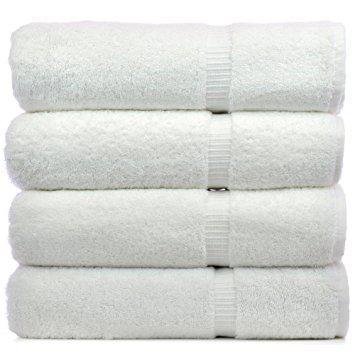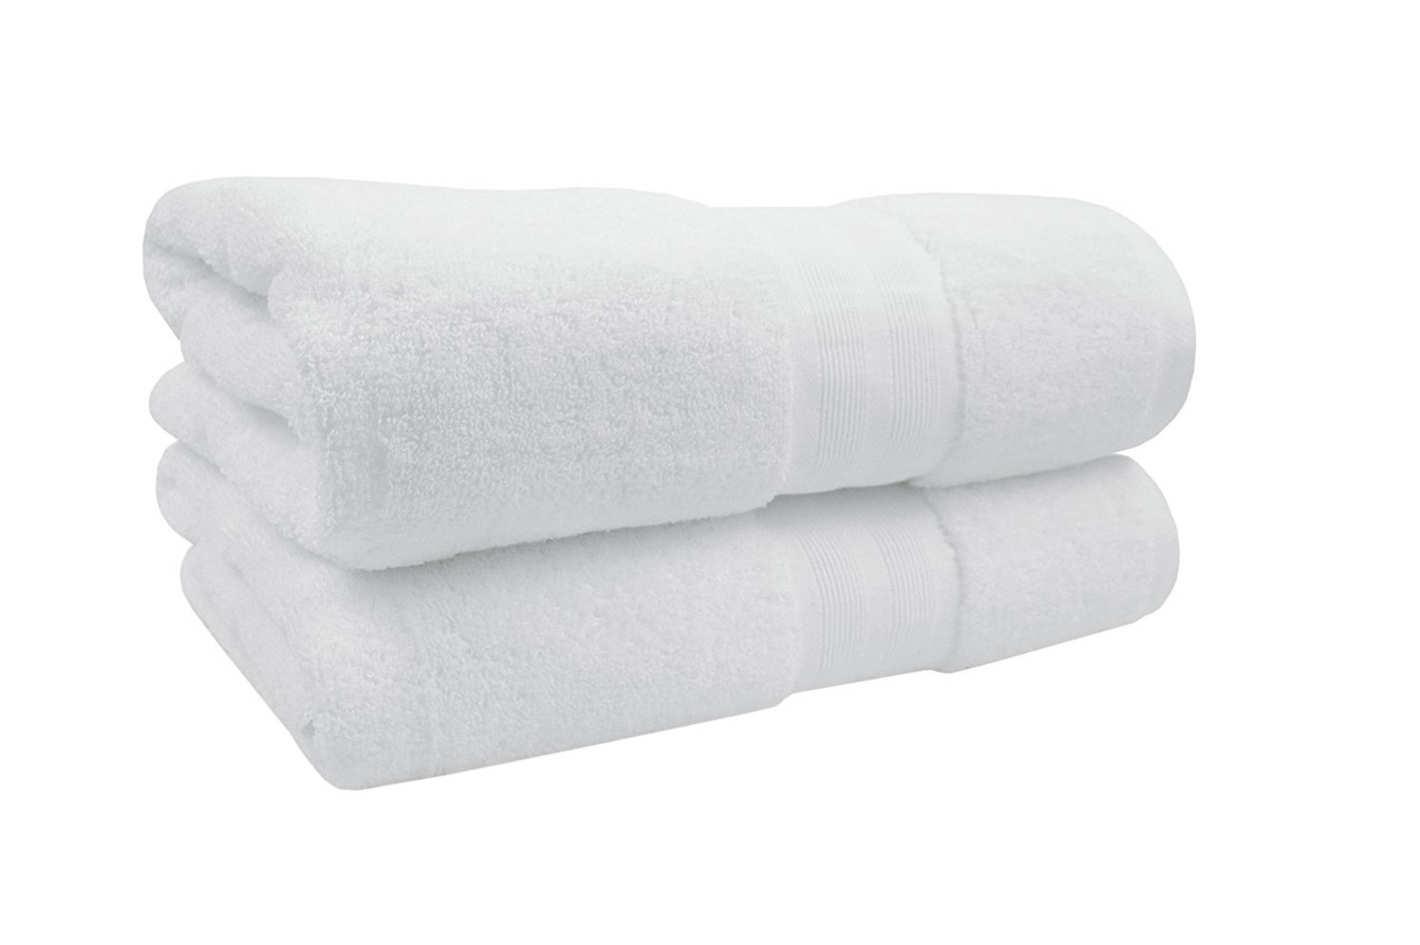The first image is the image on the left, the second image is the image on the right. Evaluate the accuracy of this statement regarding the images: "In each image there are more than two stacked towels". Is it true? Answer yes or no. No. 